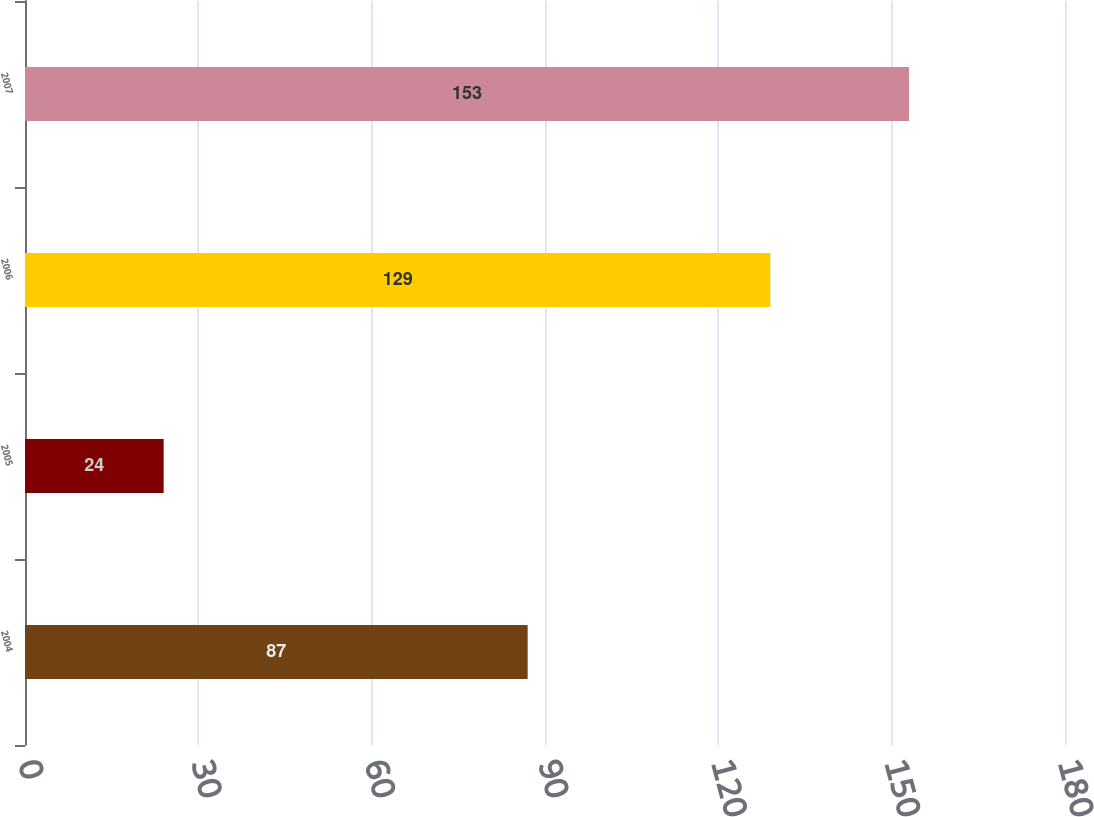Convert chart. <chart><loc_0><loc_0><loc_500><loc_500><bar_chart><fcel>2004<fcel>2005<fcel>2006<fcel>2007<nl><fcel>87<fcel>24<fcel>129<fcel>153<nl></chart> 